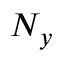Convert formula to latex. <formula><loc_0><loc_0><loc_500><loc_500>N _ { y }</formula> 